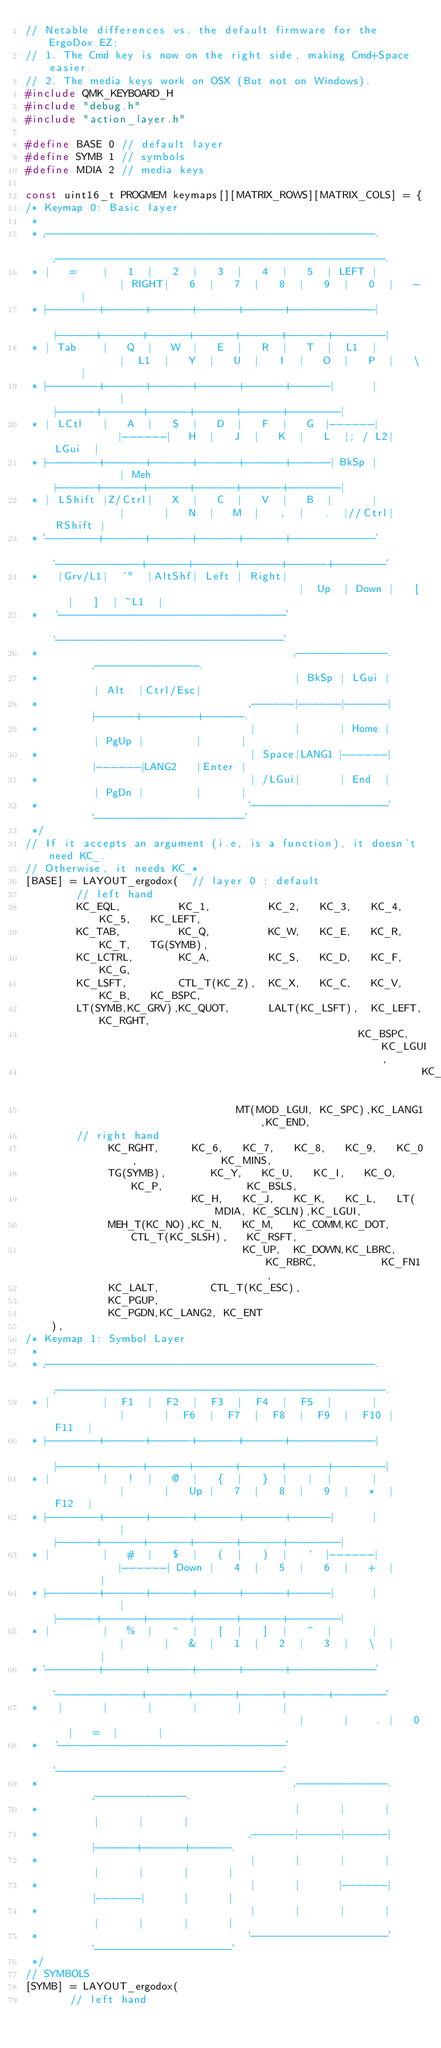Convert code to text. <code><loc_0><loc_0><loc_500><loc_500><_C_>// Netable differences vs. the default firmware for the ErgoDox EZ:
// 1. The Cmd key is now on the right side, making Cmd+Space easier.
// 2. The media keys work on OSX (But not on Windows).
#include QMK_KEYBOARD_H
#include "debug.h"
#include "action_layer.h"

#define BASE 0 // default layer
#define SYMB 1 // symbols
#define MDIA 2 // media keys

const uint16_t PROGMEM keymaps[][MATRIX_ROWS][MATRIX_COLS] = {
/* Keymap 0: Basic layer
 *
 * ,--------------------------------------------------.           ,--------------------------------------------------.
 * |   =    |   1  |   2  |   3  |   4  |   5  | LEFT |           | RIGHT|   6  |   7  |   8  |   9  |   0  |   -    |
 * |--------+------+------+------+------+-------------|           |------+------+------+------+------+------+--------|
 * | Tab    |   Q  |   W  |   E  |   R  |   T  |  L1  |           |  L1  |   Y  |   U  |   I  |   O  |   P  |   \    |
 * |--------+------+------+------+------+------|      |           |      |------+------+------+------+------+--------|
 * | LCtl   |   A  |   S  |   D  |   F  |   G  |------|           |------|   H  |   J  |   K  |   L  |; / L2|  LGui  |
 * |--------+------+------+------+------+------| BkSp |           | Meh  |------+------+------+------+------+--------|
 * | LShift |Z/Ctrl|   X  |   C  |   V  |   B  |      |           |      |   N  |   M  |   ,  |   .  |//Ctrl| RShift |
 * `--------+------+------+------+------+-------------'           `-------------+------+------+------+------+--------'
 *   |Grv/L1|  '"  |AltShf| Left | Right|                                       |  Up  | Down |   [  |   ]  | ~L1  |
 *   `----------------------------------'                                       `----------------------------------'
 *                                        ,-------------.       ,---------------.
 *                                        | BkSp | LGui |       | Alt  |Ctrl/Esc|
 *                                 ,------|------|------|       |------+--------+------.
 *                                 |      |      | Home |       | PgUp |        |      |
 *                                 | Space|LANG1 |------|       |------|LANG2   |Enter |
 *                                 | /LGui|      | End  |       | PgDn |        |      |
 *                                 `--------------------'       `----------------------'
 */
// If it accepts an argument (i.e, is a function), it doesn't need KC_.
// Otherwise, it needs KC_*
[BASE] = LAYOUT_ergodox(  // layer 0 : default
        // left hand
        KC_EQL,         KC_1,         KC_2,   KC_3,   KC_4,   KC_5,   KC_LEFT,
        KC_TAB,         KC_Q,         KC_W,   KC_E,   KC_R,   KC_T,   TG(SYMB),
        KC_LCTRL,       KC_A,         KC_S,   KC_D,   KC_F,   KC_G,
        KC_LSFT,        CTL_T(KC_Z),  KC_X,   KC_C,   KC_V,   KC_B,   KC_BSPC,
        LT(SYMB,KC_GRV),KC_QUOT,      LALT(KC_LSFT),  KC_LEFT,KC_RGHT,
                                                    KC_BSPC,  KC_LGUI,
                                                              KC_HOME,
                                 MT(MOD_LGUI, KC_SPC),KC_LANG1,KC_END,
        // right hand
             KC_RGHT,     KC_6,   KC_7,   KC_8,   KC_9,   KC_0,             KC_MINS,
             TG(SYMB),       KC_Y,   KC_U,   KC_I,   KC_O,   KC_P,             KC_BSLS,
                          KC_H,   KC_J,   KC_K,   KC_L,   LT(MDIA, KC_SCLN),KC_LGUI,
             MEH_T(KC_NO),KC_N,   KC_M,   KC_COMM,KC_DOT, CTL_T(KC_SLSH),   KC_RSFT,
                                  KC_UP,  KC_DOWN,KC_LBRC,KC_RBRC,          KC_FN1,
             KC_LALT,        CTL_T(KC_ESC),
             KC_PGUP,
             KC_PGDN,KC_LANG2, KC_ENT
    ),
/* Keymap 1: Symbol Layer
 *
 * ,--------------------------------------------------.           ,--------------------------------------------------.
 * |        |  F1  |  F2  |  F3  |  F4  |  F5  |      |           |      |  F6  |  F7  |  F8  |  F9  |  F10 |   F11  |
 * |--------+------+------+------+------+-------------|           |------+------+------+------+------+------+--------|
 * |        |   !  |   @  |   {  |   }  |   |  |      |           |      |   Up |   7  |   8  |   9  |   *  |   F12  |
 * |--------+------+------+------+------+------|      |           |      |------+------+------+------+------+--------|
 * |        |   #  |   $  |   (  |   )  |   `  |------|           |------| Down |   4  |   5  |   6  |   +  |        |
 * |--------+------+------+------+------+------|      |           |      |------+------+------+------+------+--------|
 * |        |   %  |   ^  |   [  |   ]  |   ~  |      |           |      |   &  |   1  |   2  |   3  |   \  |        |
 * `--------+------+------+------+------+-------------'           `-------------+------+------+------+------+--------'
 *   |      |      |      |      |      |                                       |      |    . |   0  |   =  |      |
 *   `----------------------------------'                                       `----------------------------------'
 *                                        ,-------------.       ,-------------.
 *                                        |      |      |       |      |      |
 *                                 ,------|------|------|       |------+------+------.
 *                                 |      |      |      |       |      |      |      |
 *                                 |      |      |------|       |------|      |      |
 *                                 |      |      |      |       |      |      |      |
 *                                 `--------------------'       `--------------------'
 */
// SYMBOLS
[SYMB] = LAYOUT_ergodox(
       // left hand</code> 